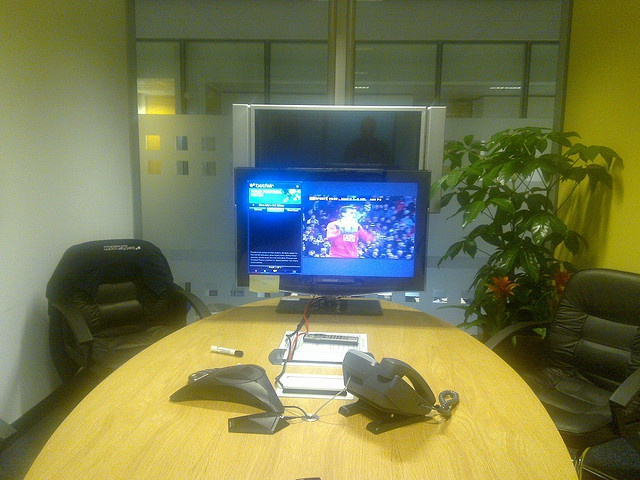Describe the objects in this image and their specific colors. I can see dining table in olive, khaki, and tan tones, tv in olive, blue, purple, and navy tones, potted plant in olive, black, darkgreen, and gray tones, chair in olive, black, and darkgreen tones, and chair in olive, black, darkgreen, and gray tones in this image. 